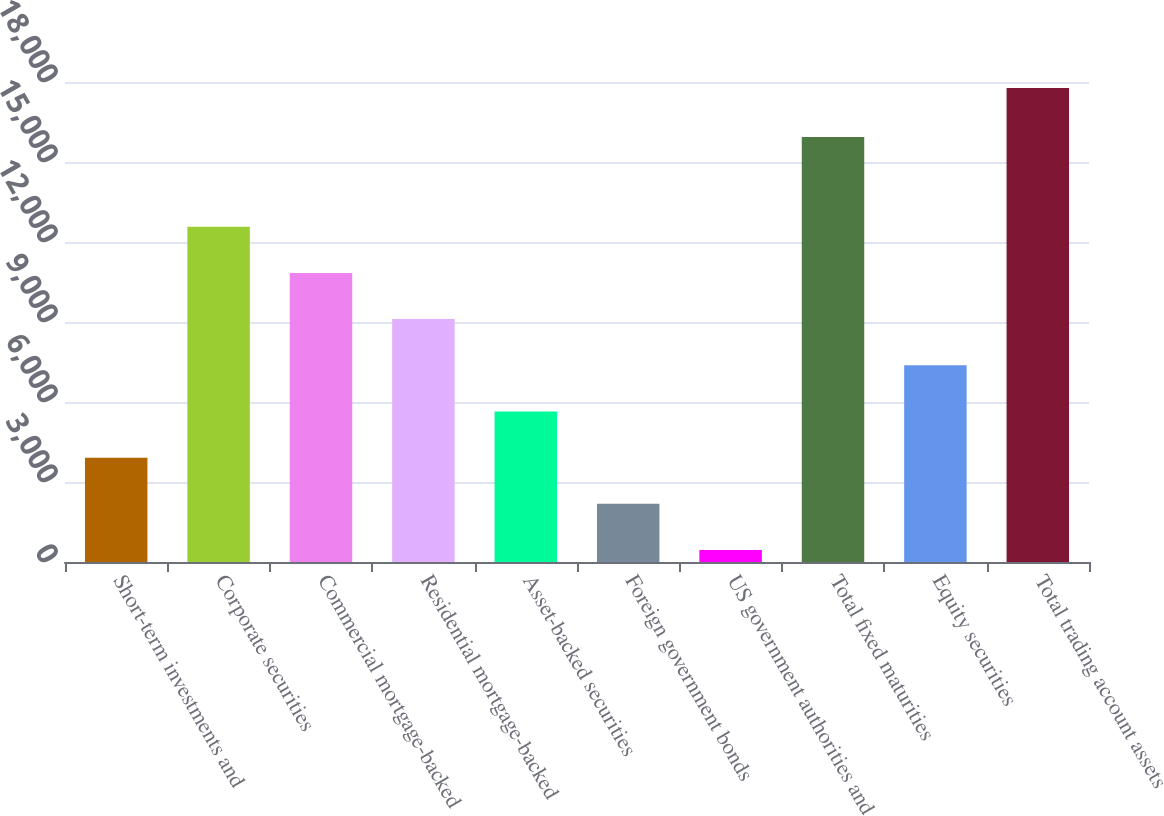<chart> <loc_0><loc_0><loc_500><loc_500><bar_chart><fcel>Short-term investments and<fcel>Corporate securities<fcel>Commercial mortgage-backed<fcel>Residential mortgage-backed<fcel>Asset-backed securities<fcel>Foreign government bonds<fcel>US government authorities and<fcel>Total fixed maturities<fcel>Equity securities<fcel>Total trading account assets<nl><fcel>3912.6<fcel>12574.1<fcel>10841.8<fcel>9109.5<fcel>5644.9<fcel>2180.3<fcel>448<fcel>15935<fcel>7377.2<fcel>17771<nl></chart> 